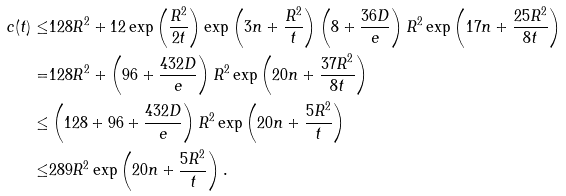Convert formula to latex. <formula><loc_0><loc_0><loc_500><loc_500>c ( t ) \leq & 1 2 8 R ^ { 2 } + 1 2 \exp \left ( \frac { R ^ { 2 } } { 2 t } \right ) \exp \left ( 3 n + \frac { R ^ { 2 } } { t } \right ) \left ( 8 + \frac { 3 6 D } { e } \right ) R ^ { 2 } \exp \left ( 1 7 n + \frac { 2 5 R ^ { 2 } } { 8 t } \right ) \\ = & 1 2 8 R ^ { 2 } + \left ( 9 6 + \frac { 4 3 2 D } { e } \right ) R ^ { 2 } \exp \left ( 2 0 n + \frac { 3 7 R ^ { 2 } } { 8 t } \right ) \\ \leq & \left ( 1 2 8 + 9 6 + \frac { 4 3 2 D } { e } \right ) R ^ { 2 } \exp \left ( 2 0 n + \frac { 5 R ^ { 2 } } { t } \right ) \\ \leq & 2 8 9 R ^ { 2 } \exp \left ( 2 0 n + \frac { 5 R ^ { 2 } } { t } \right ) .</formula> 